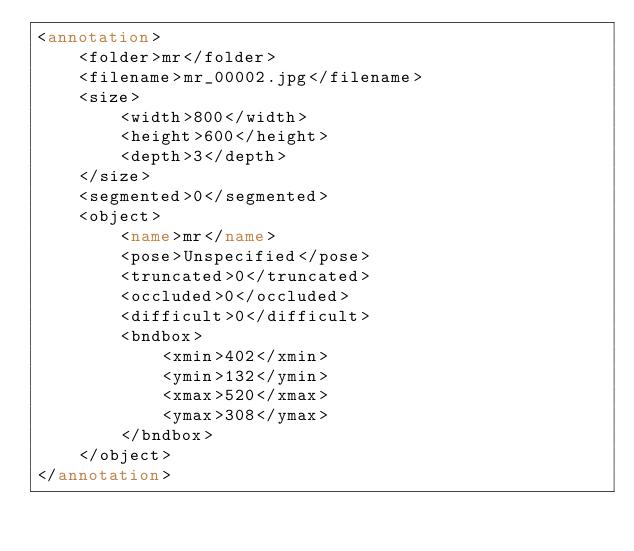Convert code to text. <code><loc_0><loc_0><loc_500><loc_500><_XML_><annotation>
    <folder>mr</folder>
    <filename>mr_00002.jpg</filename>
    <size>
        <width>800</width>
        <height>600</height>
        <depth>3</depth>
    </size>
    <segmented>0</segmented>
    <object>
        <name>mr</name>
        <pose>Unspecified</pose>
        <truncated>0</truncated>
        <occluded>0</occluded>
        <difficult>0</difficult>
        <bndbox>
            <xmin>402</xmin>
            <ymin>132</ymin>
            <xmax>520</xmax>
            <ymax>308</ymax>
        </bndbox>
    </object>
</annotation></code> 